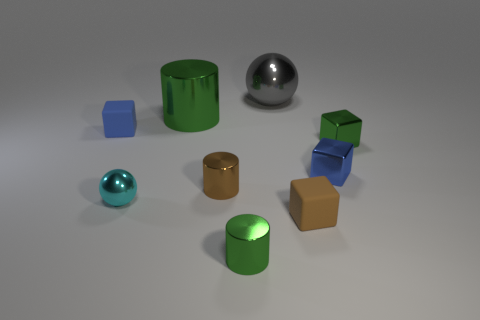Subtract all cyan cubes. How many green cylinders are left? 2 Subtract all tiny cylinders. How many cylinders are left? 1 Subtract all brown cubes. How many cubes are left? 3 Subtract 2 cubes. How many cubes are left? 2 Add 1 blue shiny things. How many objects exist? 10 Subtract all spheres. How many objects are left? 7 Subtract 0 red spheres. How many objects are left? 9 Subtract all red cylinders. Subtract all brown blocks. How many cylinders are left? 3 Subtract all green metallic cylinders. Subtract all green blocks. How many objects are left? 6 Add 9 small brown cubes. How many small brown cubes are left? 10 